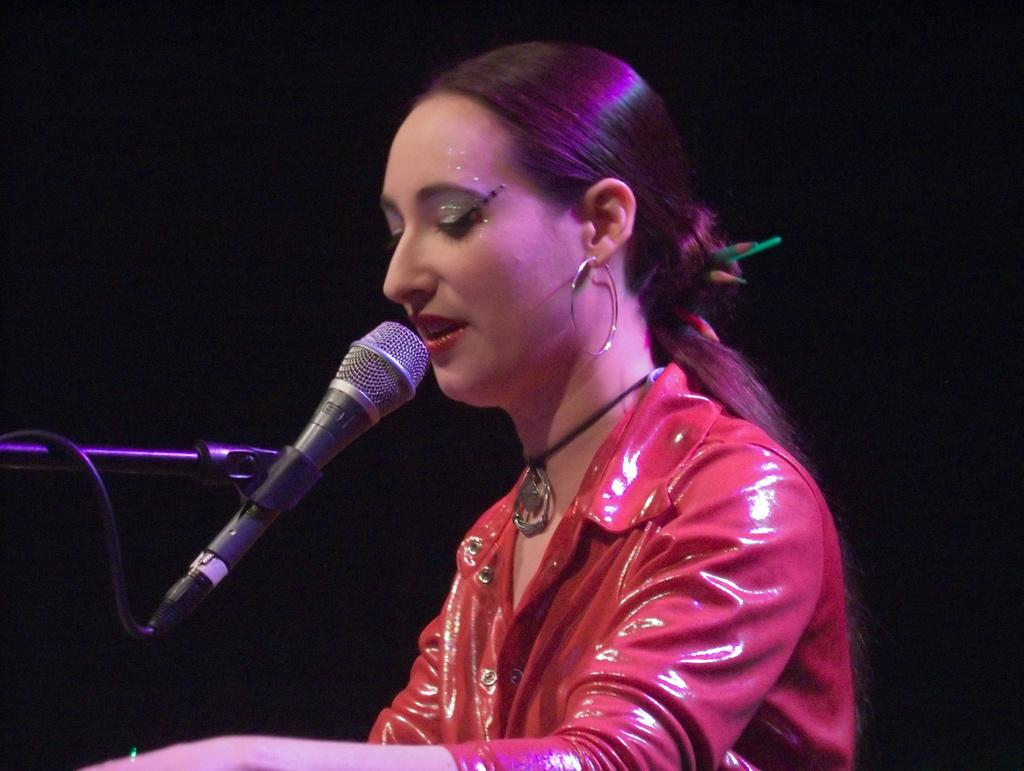What is the main subject of the image? The main subject of the image is a woman. What is the woman doing in the image? The woman is talking into a microphone. What is the woman wearing in the image? The woman is wearing a red coat. What type of disease can be seen affecting the woman in the image? There is no indication of any disease affecting the woman in the image. What type of polish is the woman using on her nails in the image? There is no indication of the woman having her nails polished in the image. 